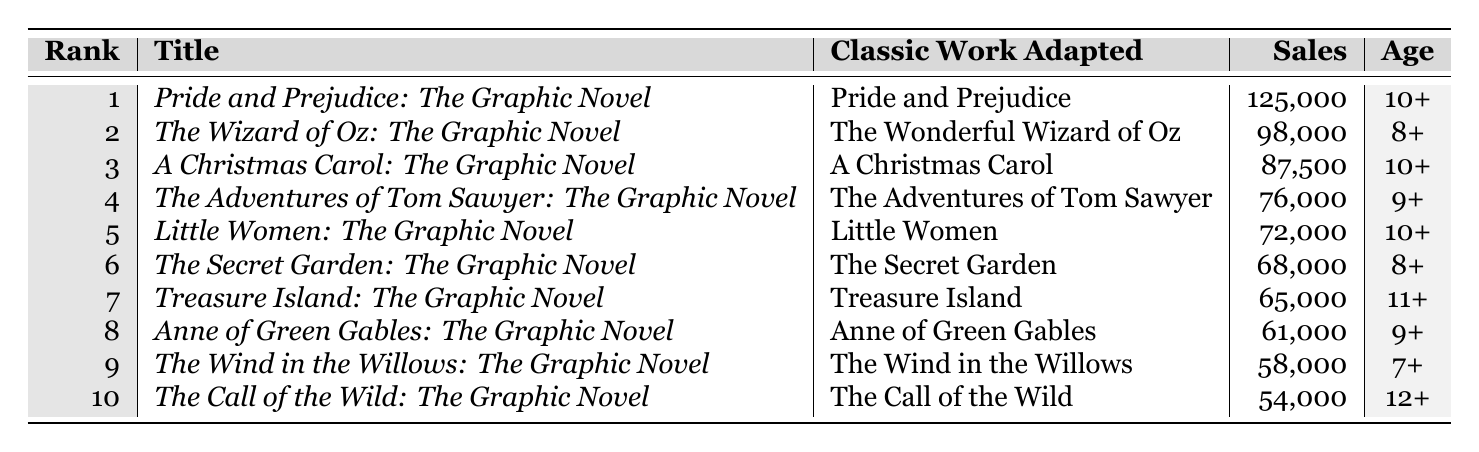What is the title of the highest-selling graphic novel adaptation? The table shows that "Pride and Prejudice: The Graphic Novel" is in the first rank with sales of 125,000 units, which is the highest.
Answer: Pride and Prejudice: The Graphic Novel Which graphic novel adaptation has sales lower than 60,000 units? Referring to the table, "The Wind in the Willows: The Graphic Novel" with sales of 58,000 units is the only one below 60,000.
Answer: The Wind in the Willows: The Graphic Novel How many units did "Little Women: The Graphic Novel" sell? The table states that "Little Women: The Graphic Novel" sold 72,000 units.
Answer: 72,000 What is the age rating of "Treasure Island: The Graphic Novel"? According to the table, "Treasure Island: The Graphic Novel" has an age rating of 11+.
Answer: 11+ Which adaptations have an age rating of 10+? The table indicates that "Pride and Prejudice: The Graphic Novel," "A Christmas Carol: The Graphic Novel," and "Little Women: The Graphic Novel" have an age rating of 10+.
Answer: Pride and Prejudice: The Graphic Novel, A Christmas Carol: The Graphic Novel, Little Women: The Graphic Novel What is the total sales for the top three graphic novel adaptations? From the data, the sales of the top three adaptations are 125,000 + 98,000 + 87,500 = 310,500 units.
Answer: 310,500 Which adaptation had the lowest sales among the top ten? The lowest sales in the table are 54,000 units for "The Call of the Wild: The Graphic Novel".
Answer: The Call of the Wild: The Graphic Novel How many graphic novels have sales greater than 70,000 units? The table lists five graphic novels with sales above 70,000 units: "Pride and Prejudice," "The Wizard of Oz," "A Christmas Carol," "The Adventures of Tom Sawyer," and "Little Women".
Answer: 5 Is there an adaptation with an age rating of 12+? "The Call of the Wild: The Graphic Novel" is the only adaptation with an age rating of 12+, as per the table.
Answer: Yes What are the average sales of graphic novels with an age rating of 10+? Sales for age-rated 10+ adaptations are 125,000 (Pride) + 87,500 (Christmas) + 72,000 (Little Women) = 284,500. There are three adaptations, so 284,500 / 3 = 94,833.33, rounded gives an average of 94,833.
Answer: 94,833 